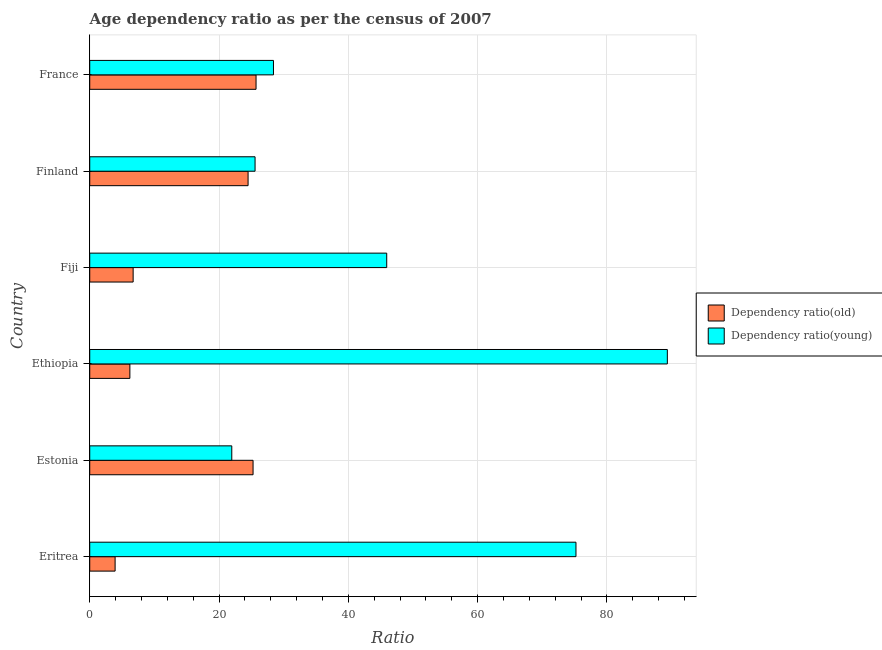Are the number of bars on each tick of the Y-axis equal?
Your answer should be very brief. Yes. What is the label of the 3rd group of bars from the top?
Your answer should be compact. Fiji. In how many cases, is the number of bars for a given country not equal to the number of legend labels?
Ensure brevity in your answer.  0. What is the age dependency ratio(young) in Ethiopia?
Make the answer very short. 89.35. Across all countries, what is the maximum age dependency ratio(young)?
Your answer should be very brief. 89.35. Across all countries, what is the minimum age dependency ratio(old)?
Your answer should be very brief. 3.93. In which country was the age dependency ratio(old) maximum?
Provide a short and direct response. France. In which country was the age dependency ratio(young) minimum?
Ensure brevity in your answer.  Estonia. What is the total age dependency ratio(old) in the graph?
Keep it short and to the point. 92.34. What is the difference between the age dependency ratio(young) in Estonia and that in France?
Keep it short and to the point. -6.45. What is the difference between the age dependency ratio(young) in Fiji and the age dependency ratio(old) in France?
Your answer should be compact. 20.21. What is the average age dependency ratio(young) per country?
Your answer should be compact. 47.74. What is the difference between the age dependency ratio(young) and age dependency ratio(old) in Estonia?
Make the answer very short. -3.29. What is the ratio of the age dependency ratio(old) in Eritrea to that in Estonia?
Your answer should be compact. 0.15. Is the difference between the age dependency ratio(old) in Estonia and Ethiopia greater than the difference between the age dependency ratio(young) in Estonia and Ethiopia?
Provide a short and direct response. Yes. What is the difference between the highest and the second highest age dependency ratio(old)?
Give a very brief answer. 0.46. What is the difference between the highest and the lowest age dependency ratio(old)?
Your response must be concise. 21.8. In how many countries, is the age dependency ratio(young) greater than the average age dependency ratio(young) taken over all countries?
Give a very brief answer. 2. What does the 2nd bar from the top in Ethiopia represents?
Give a very brief answer. Dependency ratio(old). What does the 1st bar from the bottom in Fiji represents?
Offer a terse response. Dependency ratio(old). Are all the bars in the graph horizontal?
Offer a very short reply. Yes. Are the values on the major ticks of X-axis written in scientific E-notation?
Offer a terse response. No. Does the graph contain grids?
Your response must be concise. Yes. What is the title of the graph?
Make the answer very short. Age dependency ratio as per the census of 2007. What is the label or title of the X-axis?
Keep it short and to the point. Ratio. What is the label or title of the Y-axis?
Your answer should be compact. Country. What is the Ratio of Dependency ratio(old) in Eritrea?
Offer a terse response. 3.93. What is the Ratio of Dependency ratio(young) in Eritrea?
Provide a succinct answer. 75.21. What is the Ratio of Dependency ratio(old) in Estonia?
Your answer should be compact. 25.26. What is the Ratio of Dependency ratio(young) in Estonia?
Your response must be concise. 21.97. What is the Ratio of Dependency ratio(old) in Ethiopia?
Provide a short and direct response. 6.21. What is the Ratio of Dependency ratio(young) in Ethiopia?
Offer a very short reply. 89.35. What is the Ratio in Dependency ratio(old) in Fiji?
Your answer should be compact. 6.71. What is the Ratio in Dependency ratio(young) in Fiji?
Keep it short and to the point. 45.94. What is the Ratio in Dependency ratio(old) in Finland?
Provide a short and direct response. 24.49. What is the Ratio in Dependency ratio(young) in Finland?
Keep it short and to the point. 25.57. What is the Ratio in Dependency ratio(old) in France?
Provide a succinct answer. 25.73. What is the Ratio in Dependency ratio(young) in France?
Your response must be concise. 28.42. Across all countries, what is the maximum Ratio of Dependency ratio(old)?
Offer a terse response. 25.73. Across all countries, what is the maximum Ratio in Dependency ratio(young)?
Make the answer very short. 89.35. Across all countries, what is the minimum Ratio in Dependency ratio(old)?
Provide a short and direct response. 3.93. Across all countries, what is the minimum Ratio in Dependency ratio(young)?
Offer a terse response. 21.97. What is the total Ratio of Dependency ratio(old) in the graph?
Ensure brevity in your answer.  92.34. What is the total Ratio in Dependency ratio(young) in the graph?
Make the answer very short. 286.46. What is the difference between the Ratio in Dependency ratio(old) in Eritrea and that in Estonia?
Your answer should be very brief. -21.34. What is the difference between the Ratio in Dependency ratio(young) in Eritrea and that in Estonia?
Offer a very short reply. 53.24. What is the difference between the Ratio in Dependency ratio(old) in Eritrea and that in Ethiopia?
Provide a succinct answer. -2.28. What is the difference between the Ratio in Dependency ratio(young) in Eritrea and that in Ethiopia?
Your answer should be compact. -14.13. What is the difference between the Ratio of Dependency ratio(old) in Eritrea and that in Fiji?
Your response must be concise. -2.79. What is the difference between the Ratio of Dependency ratio(young) in Eritrea and that in Fiji?
Give a very brief answer. 29.27. What is the difference between the Ratio of Dependency ratio(old) in Eritrea and that in Finland?
Your answer should be compact. -20.57. What is the difference between the Ratio of Dependency ratio(young) in Eritrea and that in Finland?
Keep it short and to the point. 49.64. What is the difference between the Ratio of Dependency ratio(old) in Eritrea and that in France?
Provide a succinct answer. -21.8. What is the difference between the Ratio in Dependency ratio(young) in Eritrea and that in France?
Offer a very short reply. 46.79. What is the difference between the Ratio in Dependency ratio(old) in Estonia and that in Ethiopia?
Provide a succinct answer. 19.05. What is the difference between the Ratio of Dependency ratio(young) in Estonia and that in Ethiopia?
Give a very brief answer. -67.37. What is the difference between the Ratio of Dependency ratio(old) in Estonia and that in Fiji?
Ensure brevity in your answer.  18.55. What is the difference between the Ratio of Dependency ratio(young) in Estonia and that in Fiji?
Offer a terse response. -23.97. What is the difference between the Ratio in Dependency ratio(old) in Estonia and that in Finland?
Keep it short and to the point. 0.77. What is the difference between the Ratio in Dependency ratio(young) in Estonia and that in Finland?
Your answer should be compact. -3.6. What is the difference between the Ratio in Dependency ratio(old) in Estonia and that in France?
Give a very brief answer. -0.46. What is the difference between the Ratio of Dependency ratio(young) in Estonia and that in France?
Offer a terse response. -6.45. What is the difference between the Ratio of Dependency ratio(old) in Ethiopia and that in Fiji?
Provide a succinct answer. -0.5. What is the difference between the Ratio in Dependency ratio(young) in Ethiopia and that in Fiji?
Give a very brief answer. 43.41. What is the difference between the Ratio in Dependency ratio(old) in Ethiopia and that in Finland?
Your response must be concise. -18.28. What is the difference between the Ratio in Dependency ratio(young) in Ethiopia and that in Finland?
Make the answer very short. 63.77. What is the difference between the Ratio in Dependency ratio(old) in Ethiopia and that in France?
Ensure brevity in your answer.  -19.52. What is the difference between the Ratio of Dependency ratio(young) in Ethiopia and that in France?
Give a very brief answer. 60.93. What is the difference between the Ratio of Dependency ratio(old) in Fiji and that in Finland?
Give a very brief answer. -17.78. What is the difference between the Ratio of Dependency ratio(young) in Fiji and that in Finland?
Ensure brevity in your answer.  20.36. What is the difference between the Ratio in Dependency ratio(old) in Fiji and that in France?
Make the answer very short. -19.01. What is the difference between the Ratio in Dependency ratio(young) in Fiji and that in France?
Keep it short and to the point. 17.52. What is the difference between the Ratio in Dependency ratio(old) in Finland and that in France?
Give a very brief answer. -1.23. What is the difference between the Ratio of Dependency ratio(young) in Finland and that in France?
Offer a very short reply. -2.85. What is the difference between the Ratio in Dependency ratio(old) in Eritrea and the Ratio in Dependency ratio(young) in Estonia?
Your answer should be compact. -18.05. What is the difference between the Ratio in Dependency ratio(old) in Eritrea and the Ratio in Dependency ratio(young) in Ethiopia?
Ensure brevity in your answer.  -85.42. What is the difference between the Ratio of Dependency ratio(old) in Eritrea and the Ratio of Dependency ratio(young) in Fiji?
Provide a succinct answer. -42.01. What is the difference between the Ratio of Dependency ratio(old) in Eritrea and the Ratio of Dependency ratio(young) in Finland?
Make the answer very short. -21.65. What is the difference between the Ratio in Dependency ratio(old) in Eritrea and the Ratio in Dependency ratio(young) in France?
Provide a short and direct response. -24.49. What is the difference between the Ratio in Dependency ratio(old) in Estonia and the Ratio in Dependency ratio(young) in Ethiopia?
Offer a very short reply. -64.08. What is the difference between the Ratio in Dependency ratio(old) in Estonia and the Ratio in Dependency ratio(young) in Fiji?
Your response must be concise. -20.67. What is the difference between the Ratio in Dependency ratio(old) in Estonia and the Ratio in Dependency ratio(young) in Finland?
Provide a succinct answer. -0.31. What is the difference between the Ratio in Dependency ratio(old) in Estonia and the Ratio in Dependency ratio(young) in France?
Provide a succinct answer. -3.16. What is the difference between the Ratio in Dependency ratio(old) in Ethiopia and the Ratio in Dependency ratio(young) in Fiji?
Make the answer very short. -39.73. What is the difference between the Ratio in Dependency ratio(old) in Ethiopia and the Ratio in Dependency ratio(young) in Finland?
Your answer should be compact. -19.36. What is the difference between the Ratio in Dependency ratio(old) in Ethiopia and the Ratio in Dependency ratio(young) in France?
Offer a very short reply. -22.21. What is the difference between the Ratio of Dependency ratio(old) in Fiji and the Ratio of Dependency ratio(young) in Finland?
Offer a terse response. -18.86. What is the difference between the Ratio of Dependency ratio(old) in Fiji and the Ratio of Dependency ratio(young) in France?
Offer a terse response. -21.71. What is the difference between the Ratio in Dependency ratio(old) in Finland and the Ratio in Dependency ratio(young) in France?
Keep it short and to the point. -3.93. What is the average Ratio of Dependency ratio(old) per country?
Provide a succinct answer. 15.39. What is the average Ratio in Dependency ratio(young) per country?
Offer a very short reply. 47.74. What is the difference between the Ratio of Dependency ratio(old) and Ratio of Dependency ratio(young) in Eritrea?
Offer a terse response. -71.29. What is the difference between the Ratio of Dependency ratio(old) and Ratio of Dependency ratio(young) in Estonia?
Provide a short and direct response. 3.29. What is the difference between the Ratio of Dependency ratio(old) and Ratio of Dependency ratio(young) in Ethiopia?
Make the answer very short. -83.14. What is the difference between the Ratio in Dependency ratio(old) and Ratio in Dependency ratio(young) in Fiji?
Make the answer very short. -39.22. What is the difference between the Ratio in Dependency ratio(old) and Ratio in Dependency ratio(young) in Finland?
Your answer should be very brief. -1.08. What is the difference between the Ratio in Dependency ratio(old) and Ratio in Dependency ratio(young) in France?
Make the answer very short. -2.69. What is the ratio of the Ratio in Dependency ratio(old) in Eritrea to that in Estonia?
Your answer should be compact. 0.16. What is the ratio of the Ratio in Dependency ratio(young) in Eritrea to that in Estonia?
Provide a short and direct response. 3.42. What is the ratio of the Ratio of Dependency ratio(old) in Eritrea to that in Ethiopia?
Give a very brief answer. 0.63. What is the ratio of the Ratio in Dependency ratio(young) in Eritrea to that in Ethiopia?
Offer a terse response. 0.84. What is the ratio of the Ratio in Dependency ratio(old) in Eritrea to that in Fiji?
Ensure brevity in your answer.  0.58. What is the ratio of the Ratio in Dependency ratio(young) in Eritrea to that in Fiji?
Your answer should be very brief. 1.64. What is the ratio of the Ratio in Dependency ratio(old) in Eritrea to that in Finland?
Provide a short and direct response. 0.16. What is the ratio of the Ratio of Dependency ratio(young) in Eritrea to that in Finland?
Your response must be concise. 2.94. What is the ratio of the Ratio of Dependency ratio(old) in Eritrea to that in France?
Your response must be concise. 0.15. What is the ratio of the Ratio of Dependency ratio(young) in Eritrea to that in France?
Your response must be concise. 2.65. What is the ratio of the Ratio in Dependency ratio(old) in Estonia to that in Ethiopia?
Provide a succinct answer. 4.07. What is the ratio of the Ratio of Dependency ratio(young) in Estonia to that in Ethiopia?
Your response must be concise. 0.25. What is the ratio of the Ratio in Dependency ratio(old) in Estonia to that in Fiji?
Provide a succinct answer. 3.76. What is the ratio of the Ratio in Dependency ratio(young) in Estonia to that in Fiji?
Keep it short and to the point. 0.48. What is the ratio of the Ratio in Dependency ratio(old) in Estonia to that in Finland?
Provide a succinct answer. 1.03. What is the ratio of the Ratio in Dependency ratio(young) in Estonia to that in Finland?
Your answer should be compact. 0.86. What is the ratio of the Ratio of Dependency ratio(young) in Estonia to that in France?
Ensure brevity in your answer.  0.77. What is the ratio of the Ratio of Dependency ratio(old) in Ethiopia to that in Fiji?
Keep it short and to the point. 0.93. What is the ratio of the Ratio in Dependency ratio(young) in Ethiopia to that in Fiji?
Your answer should be very brief. 1.94. What is the ratio of the Ratio of Dependency ratio(old) in Ethiopia to that in Finland?
Ensure brevity in your answer.  0.25. What is the ratio of the Ratio of Dependency ratio(young) in Ethiopia to that in Finland?
Provide a short and direct response. 3.49. What is the ratio of the Ratio in Dependency ratio(old) in Ethiopia to that in France?
Your response must be concise. 0.24. What is the ratio of the Ratio in Dependency ratio(young) in Ethiopia to that in France?
Keep it short and to the point. 3.14. What is the ratio of the Ratio in Dependency ratio(old) in Fiji to that in Finland?
Provide a succinct answer. 0.27. What is the ratio of the Ratio in Dependency ratio(young) in Fiji to that in Finland?
Your response must be concise. 1.8. What is the ratio of the Ratio in Dependency ratio(old) in Fiji to that in France?
Give a very brief answer. 0.26. What is the ratio of the Ratio in Dependency ratio(young) in Fiji to that in France?
Offer a very short reply. 1.62. What is the ratio of the Ratio of Dependency ratio(old) in Finland to that in France?
Offer a terse response. 0.95. What is the ratio of the Ratio in Dependency ratio(young) in Finland to that in France?
Ensure brevity in your answer.  0.9. What is the difference between the highest and the second highest Ratio in Dependency ratio(old)?
Your response must be concise. 0.46. What is the difference between the highest and the second highest Ratio of Dependency ratio(young)?
Ensure brevity in your answer.  14.13. What is the difference between the highest and the lowest Ratio in Dependency ratio(old)?
Offer a very short reply. 21.8. What is the difference between the highest and the lowest Ratio in Dependency ratio(young)?
Offer a terse response. 67.37. 